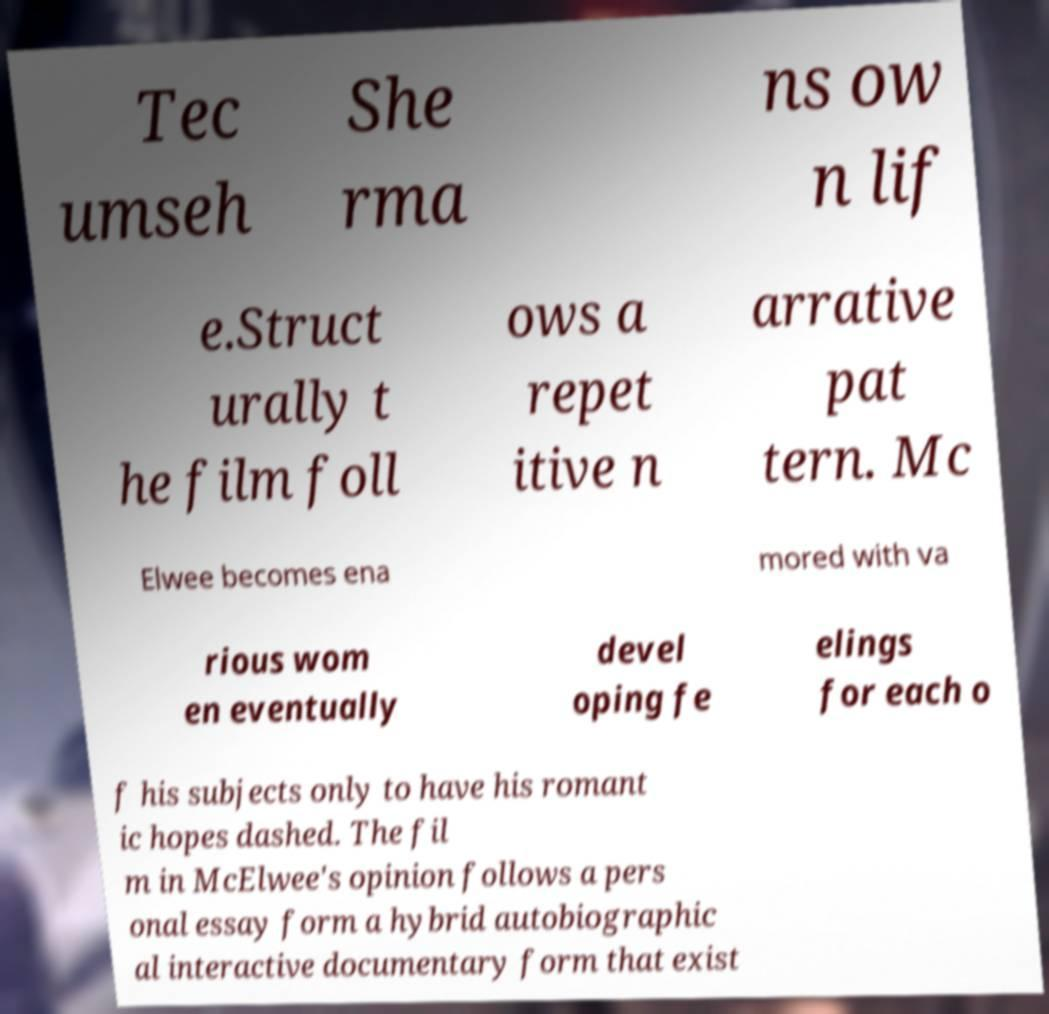Can you read and provide the text displayed in the image?This photo seems to have some interesting text. Can you extract and type it out for me? Tec umseh She rma ns ow n lif e.Struct urally t he film foll ows a repet itive n arrative pat tern. Mc Elwee becomes ena mored with va rious wom en eventually devel oping fe elings for each o f his subjects only to have his romant ic hopes dashed. The fil m in McElwee's opinion follows a pers onal essay form a hybrid autobiographic al interactive documentary form that exist 